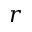<formula> <loc_0><loc_0><loc_500><loc_500>r</formula> 